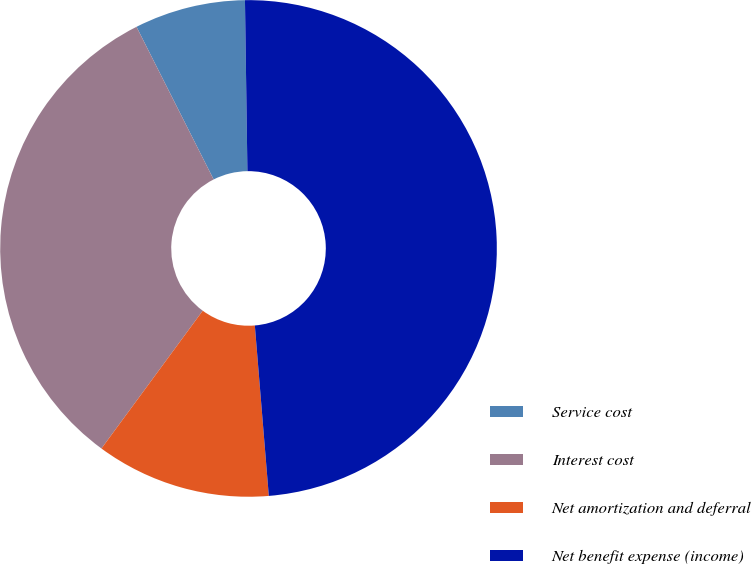Convert chart to OTSL. <chart><loc_0><loc_0><loc_500><loc_500><pie_chart><fcel>Service cost<fcel>Interest cost<fcel>Net amortization and deferral<fcel>Net benefit expense (income)<nl><fcel>7.22%<fcel>32.46%<fcel>11.39%<fcel>48.92%<nl></chart> 